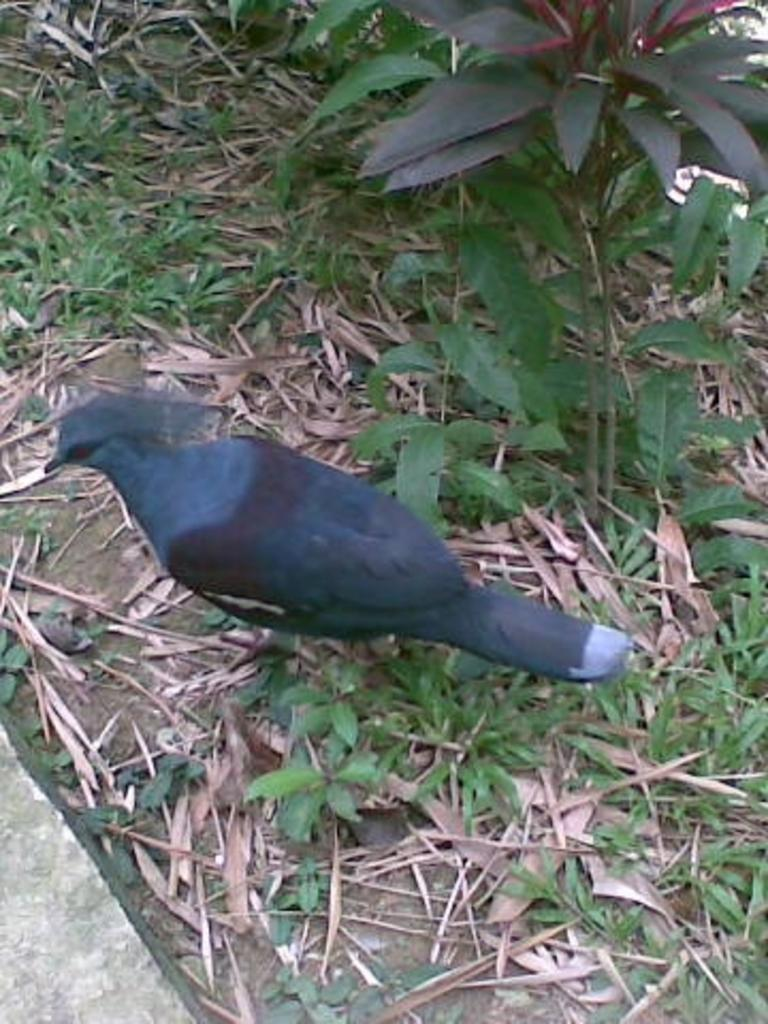What type of bird can be seen in the image? There is a black color bird in the image. Where is the bird located in the image? The bird is on the ground. What can be seen in the background of the image? There are plants visible in the image. What else is present on the ground in the image? Dry leaves are present in the image. What type of throne does the bird sit on in the image? There is no throne present in the image; the bird is on the ground. How does the bird's memory help it navigate in the image? The bird's memory is not mentioned in the image, and therefore its role in navigation cannot be determined. 